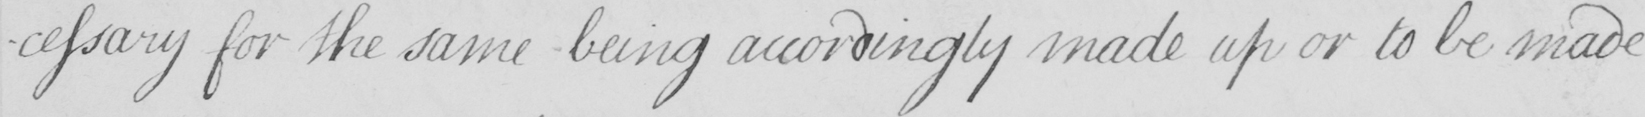What text is written in this handwritten line? -cessary for the same being accordingly made up or to be made 